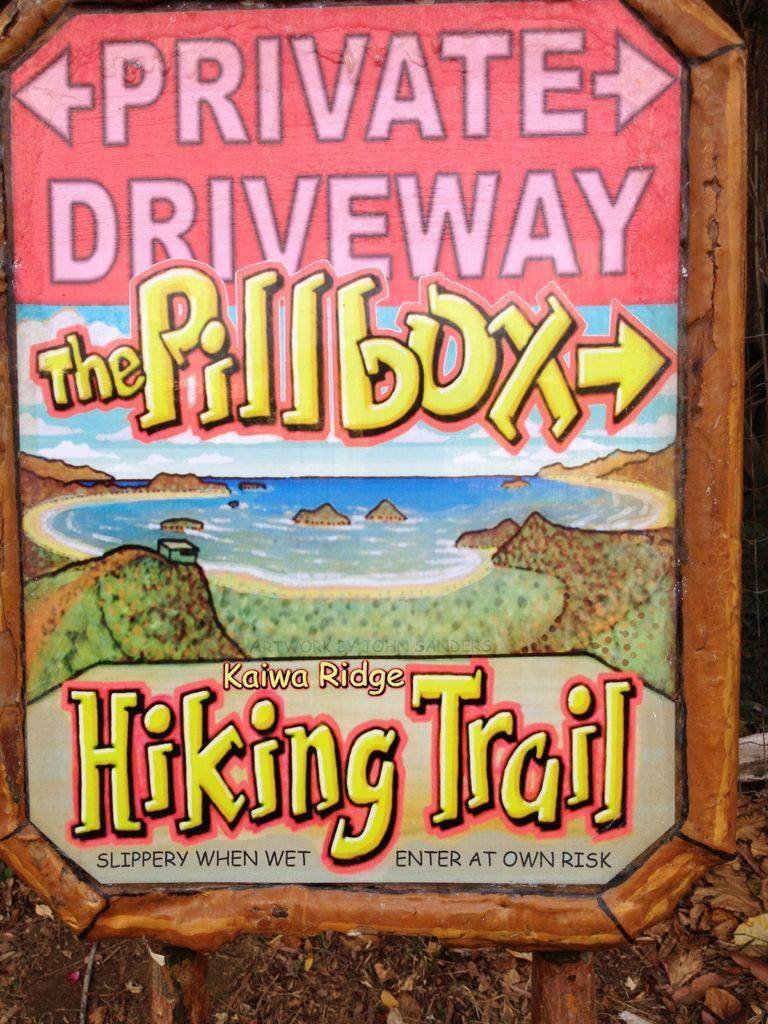<image>
Share a concise interpretation of the image provided. The hiking trail has parking spaces near where the trail starts. 